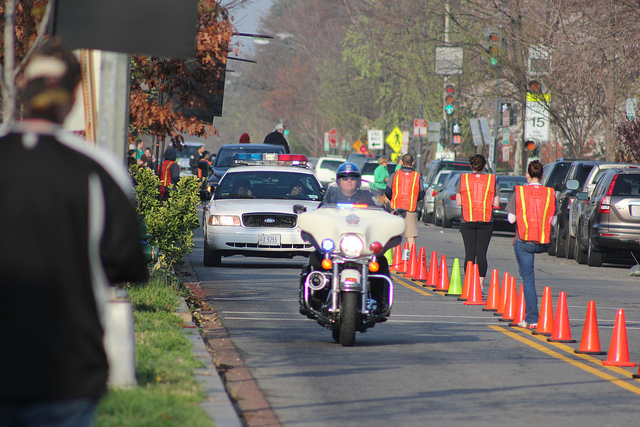Is it possible to determine the weather condition from the image? Judging by the clear skies and the shadows cast on the road, it seems that it's a sunny day. The visibility is good, which is favorable for the event or activity that's taking place. 